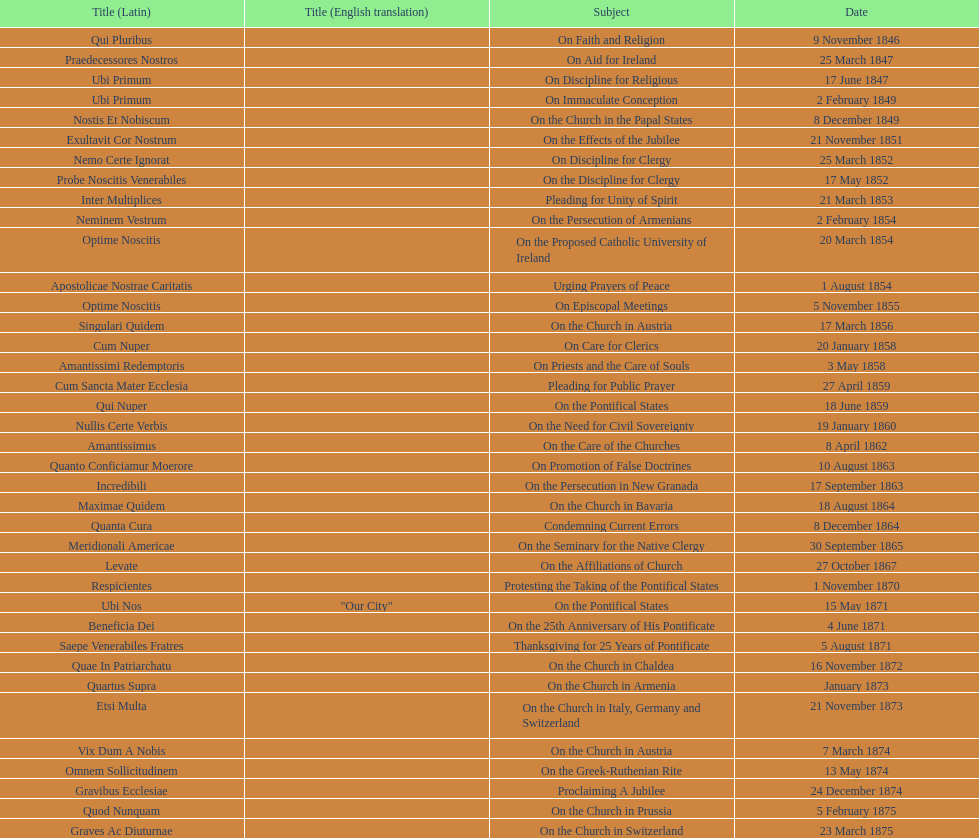Could you parse the entire table? {'header': ['Title (Latin)', 'Title (English translation)', 'Subject', 'Date'], 'rows': [['Qui Pluribus', '', 'On Faith and Religion', '9 November 1846'], ['Praedecessores Nostros', '', 'On Aid for Ireland', '25 March 1847'], ['Ubi Primum', '', 'On Discipline for Religious', '17 June 1847'], ['Ubi Primum', '', 'On Immaculate Conception', '2 February 1849'], ['Nostis Et Nobiscum', '', 'On the Church in the Papal States', '8 December 1849'], ['Exultavit Cor Nostrum', '', 'On the Effects of the Jubilee', '21 November 1851'], ['Nemo Certe Ignorat', '', 'On Discipline for Clergy', '25 March 1852'], ['Probe Noscitis Venerabiles', '', 'On the Discipline for Clergy', '17 May 1852'], ['Inter Multiplices', '', 'Pleading for Unity of Spirit', '21 March 1853'], ['Neminem Vestrum', '', 'On the Persecution of Armenians', '2 February 1854'], ['Optime Noscitis', '', 'On the Proposed Catholic University of Ireland', '20 March 1854'], ['Apostolicae Nostrae Caritatis', '', 'Urging Prayers of Peace', '1 August 1854'], ['Optime Noscitis', '', 'On Episcopal Meetings', '5 November 1855'], ['Singulari Quidem', '', 'On the Church in Austria', '17 March 1856'], ['Cum Nuper', '', 'On Care for Clerics', '20 January 1858'], ['Amantissimi Redemptoris', '', 'On Priests and the Care of Souls', '3 May 1858'], ['Cum Sancta Mater Ecclesia', '', 'Pleading for Public Prayer', '27 April 1859'], ['Qui Nuper', '', 'On the Pontifical States', '18 June 1859'], ['Nullis Certe Verbis', '', 'On the Need for Civil Sovereignty', '19 January 1860'], ['Amantissimus', '', 'On the Care of the Churches', '8 April 1862'], ['Quanto Conficiamur Moerore', '', 'On Promotion of False Doctrines', '10 August 1863'], ['Incredibili', '', 'On the Persecution in New Granada', '17 September 1863'], ['Maximae Quidem', '', 'On the Church in Bavaria', '18 August 1864'], ['Quanta Cura', '', 'Condemning Current Errors', '8 December 1864'], ['Meridionali Americae', '', 'On the Seminary for the Native Clergy', '30 September 1865'], ['Levate', '', 'On the Affiliations of Church', '27 October 1867'], ['Respicientes', '', 'Protesting the Taking of the Pontifical States', '1 November 1870'], ['Ubi Nos', '"Our City"', 'On the Pontifical States', '15 May 1871'], ['Beneficia Dei', '', 'On the 25th Anniversary of His Pontificate', '4 June 1871'], ['Saepe Venerabiles Fratres', '', 'Thanksgiving for 25 Years of Pontificate', '5 August 1871'], ['Quae In Patriarchatu', '', 'On the Church in Chaldea', '16 November 1872'], ['Quartus Supra', '', 'On the Church in Armenia', 'January 1873'], ['Etsi Multa', '', 'On the Church in Italy, Germany and Switzerland', '21 November 1873'], ['Vix Dum A Nobis', '', 'On the Church in Austria', '7 March 1874'], ['Omnem Sollicitudinem', '', 'On the Greek-Ruthenian Rite', '13 May 1874'], ['Gravibus Ecclesiae', '', 'Proclaiming A Jubilee', '24 December 1874'], ['Quod Nunquam', '', 'On the Church in Prussia', '5 February 1875'], ['Graves Ac Diuturnae', '', 'On the Church in Switzerland', '23 March 1875']]} How often was an encyclical sent in january? 3. 